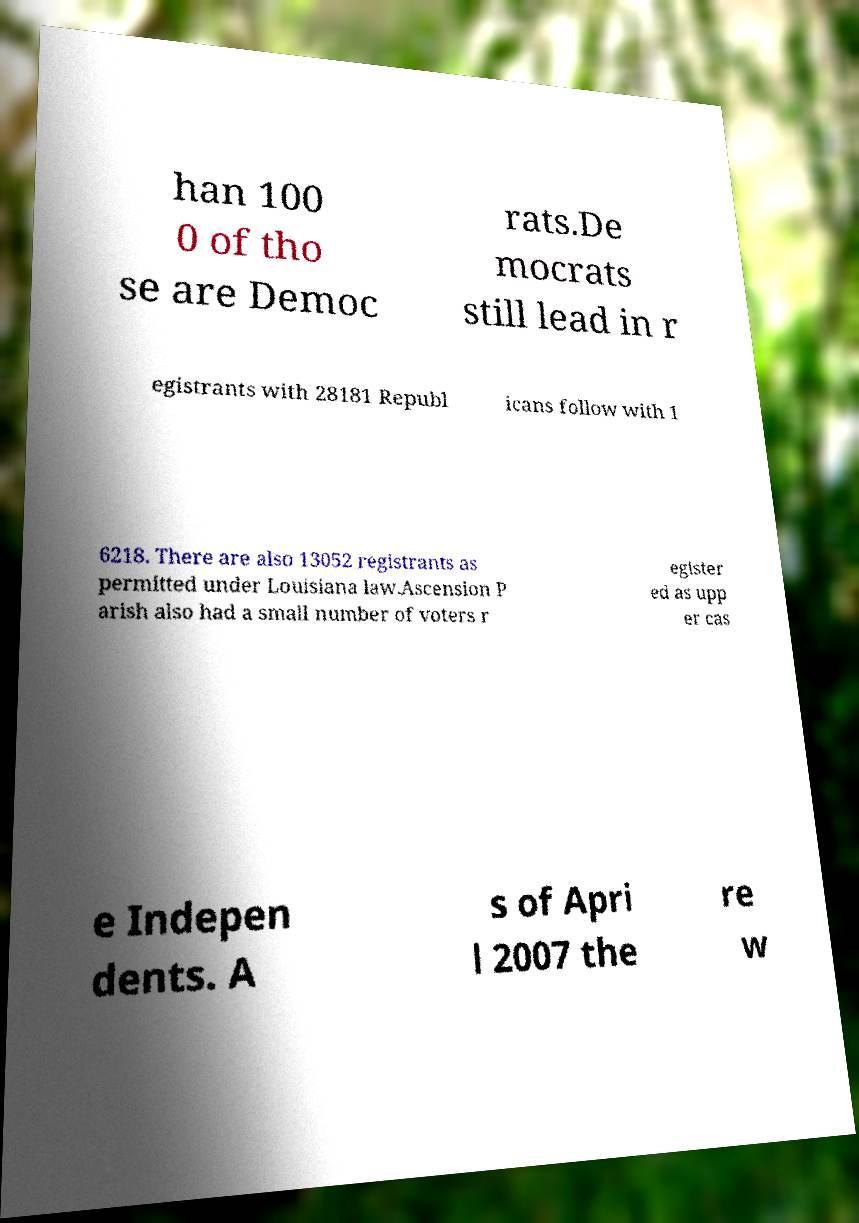Please identify and transcribe the text found in this image. han 100 0 of tho se are Democ rats.De mocrats still lead in r egistrants with 28181 Republ icans follow with 1 6218. There are also 13052 registrants as permitted under Louisiana law.Ascension P arish also had a small number of voters r egister ed as upp er cas e Indepen dents. A s of Apri l 2007 the re w 